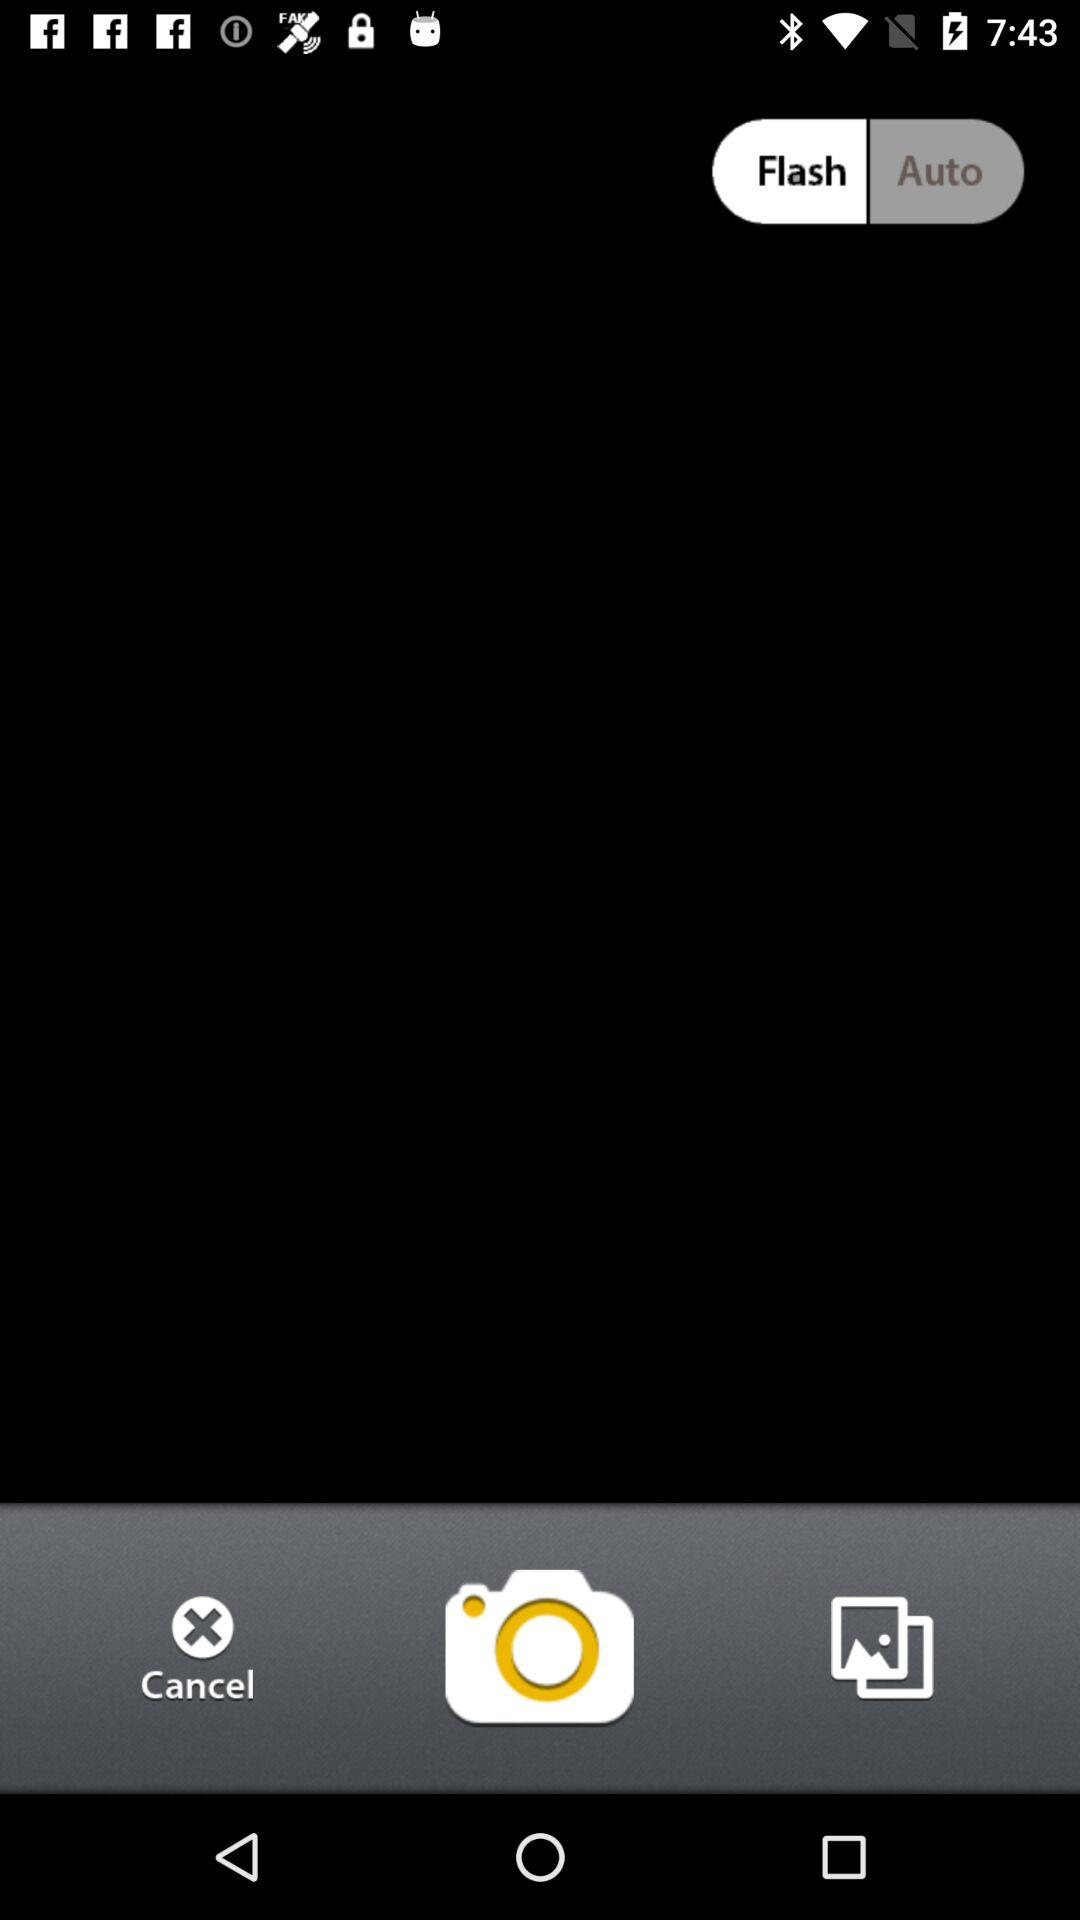What is the selected option? The selected option is "Flash". 